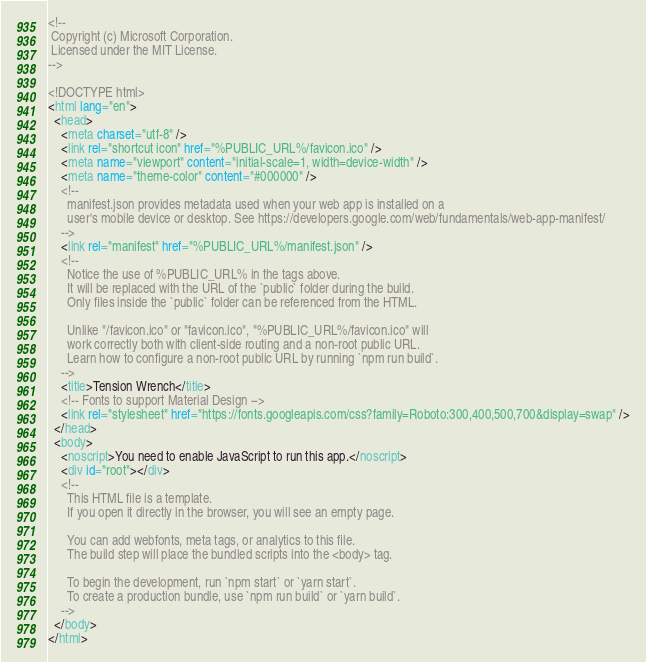Convert code to text. <code><loc_0><loc_0><loc_500><loc_500><_HTML_><!--
 Copyright (c) Microsoft Corporation.
 Licensed under the MIT License.
-->

<!DOCTYPE html>
<html lang="en">
  <head>
    <meta charset="utf-8" />
    <link rel="shortcut icon" href="%PUBLIC_URL%/favicon.ico" />
    <meta name="viewport" content="initial-scale=1, width=device-width" />
    <meta name="theme-color" content="#000000" />
    <!--
      manifest.json provides metadata used when your web app is installed on a
      user's mobile device or desktop. See https://developers.google.com/web/fundamentals/web-app-manifest/
    -->
    <link rel="manifest" href="%PUBLIC_URL%/manifest.json" />
    <!--
      Notice the use of %PUBLIC_URL% in the tags above.
      It will be replaced with the URL of the `public` folder during the build.
      Only files inside the `public` folder can be referenced from the HTML.

      Unlike "/favicon.ico" or "favicon.ico", "%PUBLIC_URL%/favicon.ico" will
      work correctly both with client-side routing and a non-root public URL.
      Learn how to configure a non-root public URL by running `npm run build`.
    -->
    <title>Tension Wrench</title>
    <!-- Fonts to support Material Design -->
    <link rel="stylesheet" href="https://fonts.googleapis.com/css?family=Roboto:300,400,500,700&display=swap" />
  </head>
  <body>
    <noscript>You need to enable JavaScript to run this app.</noscript>
    <div id="root"></div>
    <!--
      This HTML file is a template.
      If you open it directly in the browser, you will see an empty page.

      You can add webfonts, meta tags, or analytics to this file.
      The build step will place the bundled scripts into the <body> tag.

      To begin the development, run `npm start` or `yarn start`.
      To create a production bundle, use `npm run build` or `yarn build`.
    -->
  </body>
</html>
</code> 